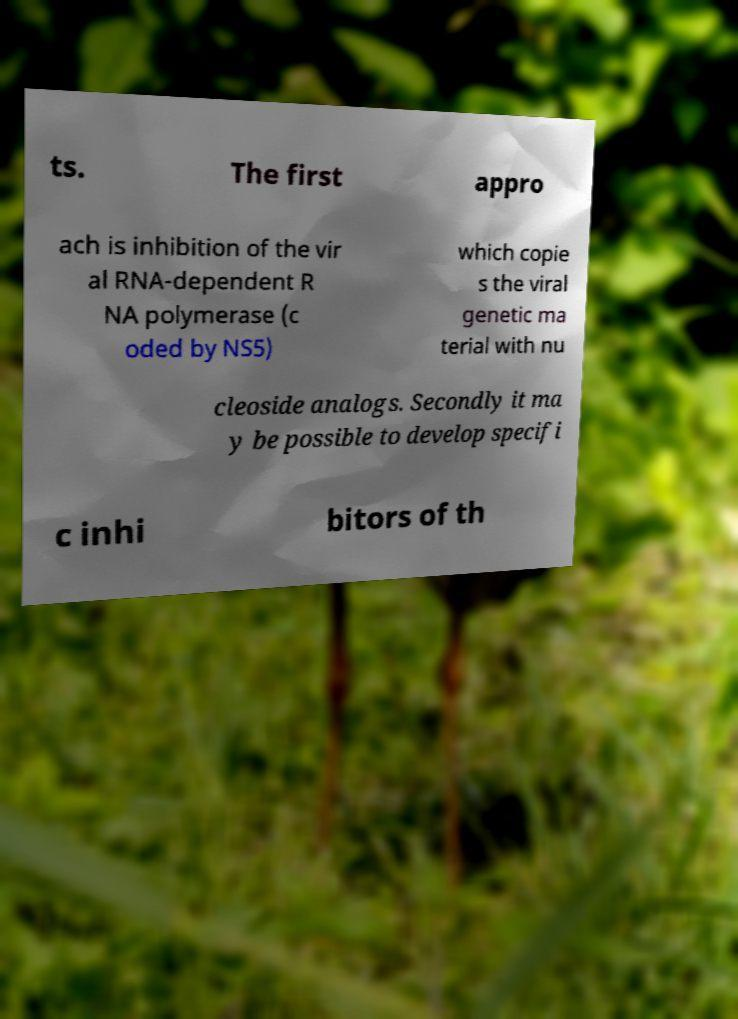For documentation purposes, I need the text within this image transcribed. Could you provide that? ts. The first appro ach is inhibition of the vir al RNA-dependent R NA polymerase (c oded by NS5) which copie s the viral genetic ma terial with nu cleoside analogs. Secondly it ma y be possible to develop specifi c inhi bitors of th 